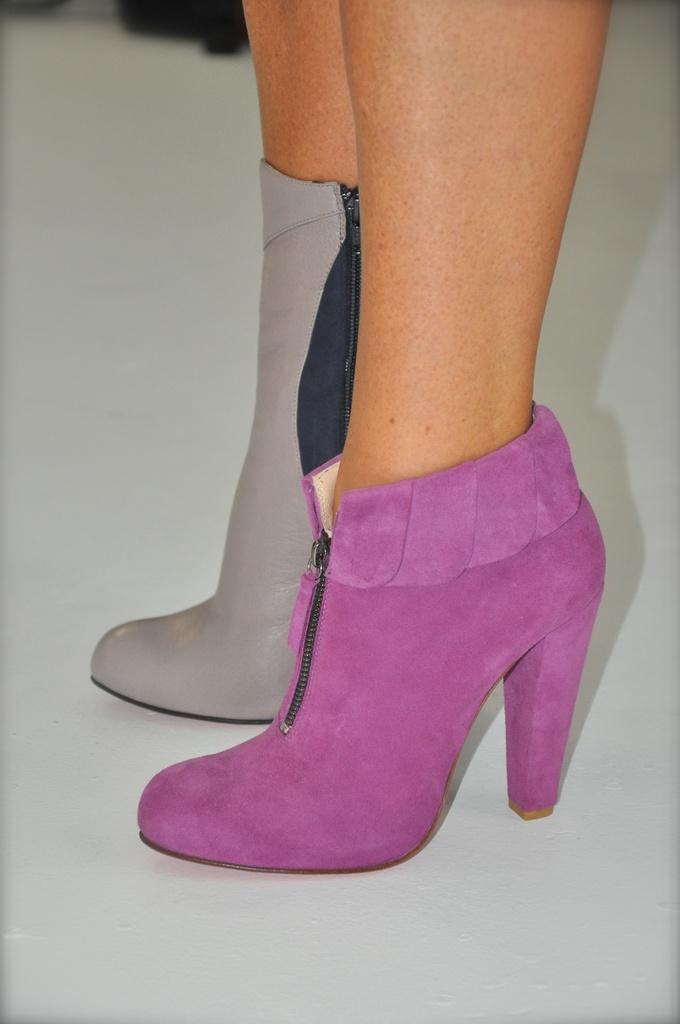In one or two sentences, can you explain what this image depicts? In the center of this picture we can see the legs of a person wearing different color boots and standing on the floor. In the background there is a black color object. 